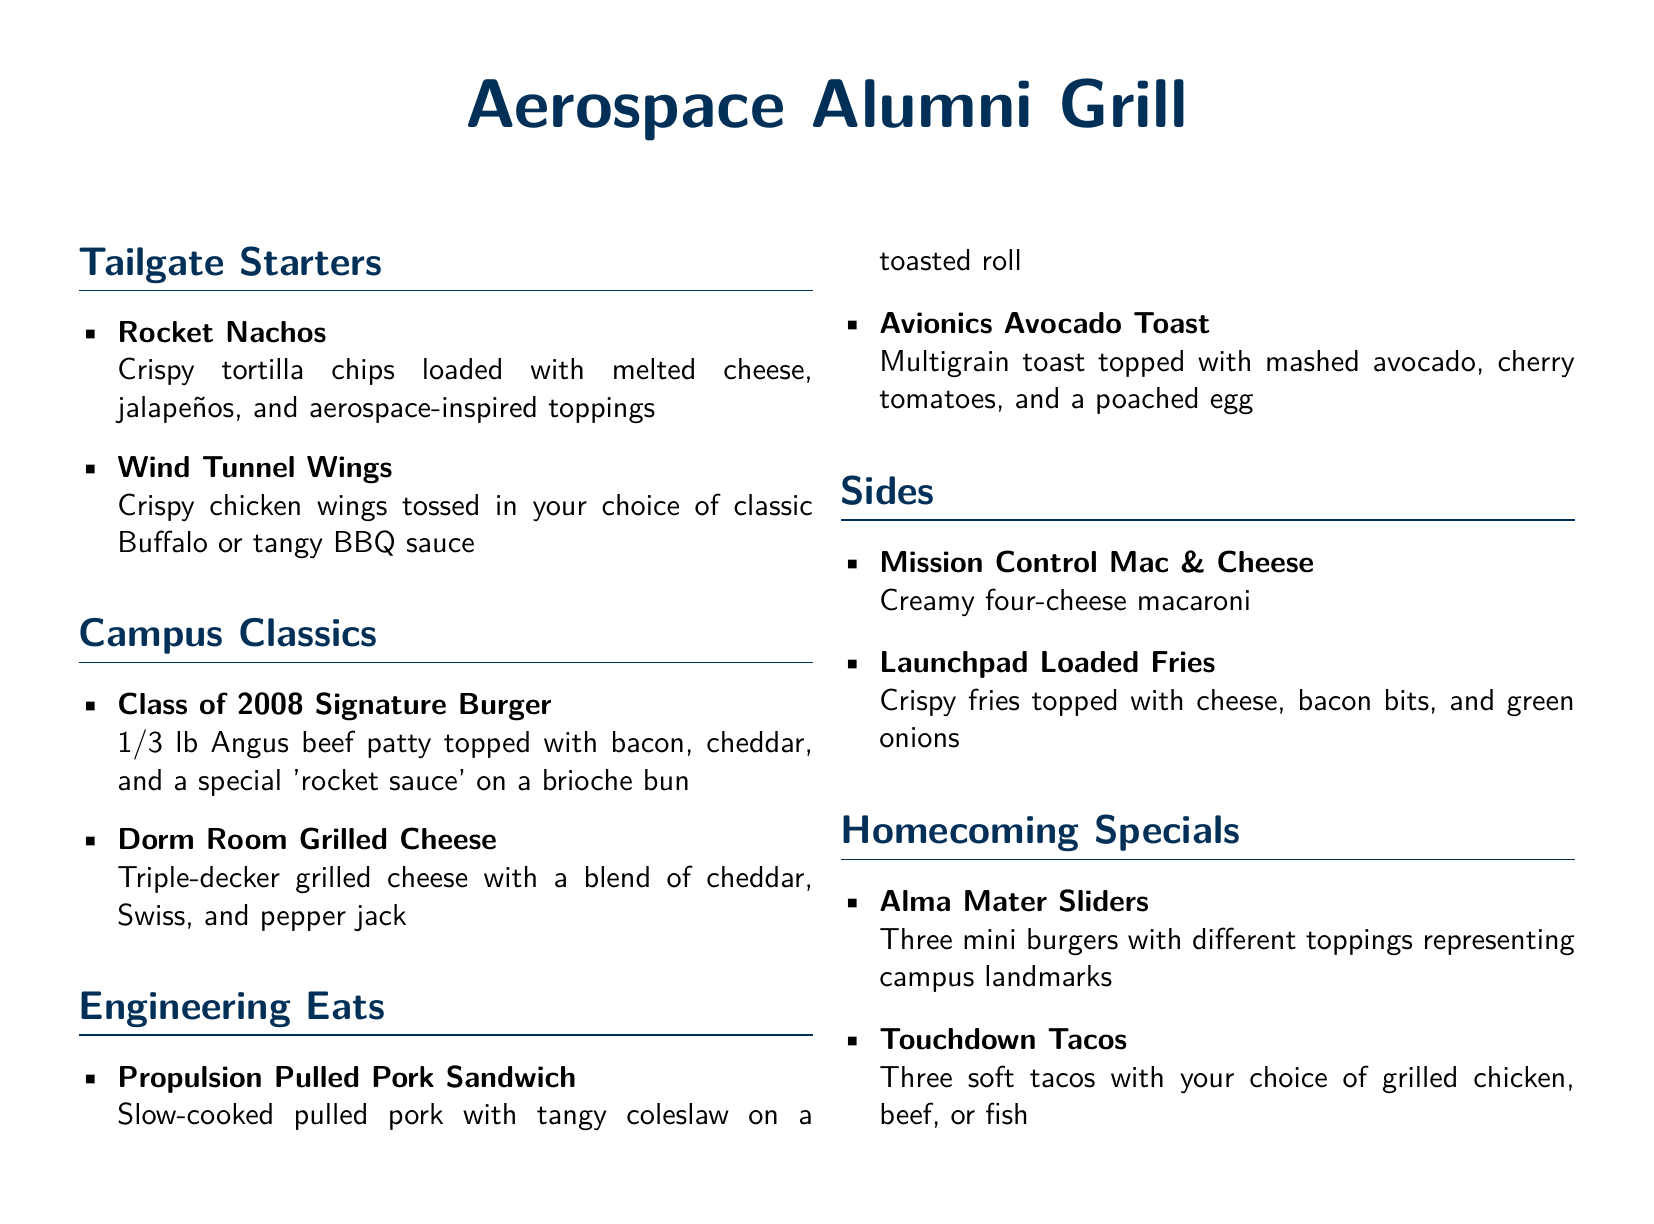What is the name of the signature burger for the Class of 2008? The Class of 2008 Signature Burger is a specific item listed under Campus Classics.
Answer: Class of 2008 Signature Burger How many mini burgers are served in the Alma Mater Sliders? The Alma Mater Sliders is described to contain three mini burgers.
Answer: Three What toppings are included in the Wind Tunnel Wings? The Wind Tunnel Wings are tossed in either classic Buffalo or tangy BBQ sauce, indicating the options for toppings.
Answer: Classic Buffalo or tangy BBQ sauce Which dish includes avocado? The Avionics Avocado Toast specifically mentions it has mashed avocado as a primary ingredient.
Answer: Avionics Avocado Toast What type of cheese is used in the Dorm Room Grilled Cheese? The Dorm Room Grilled Cheese is described to use a blend of cheddar, Swiss, and pepper jack cheese.
Answer: Cheddar, Swiss, and pepper jack 